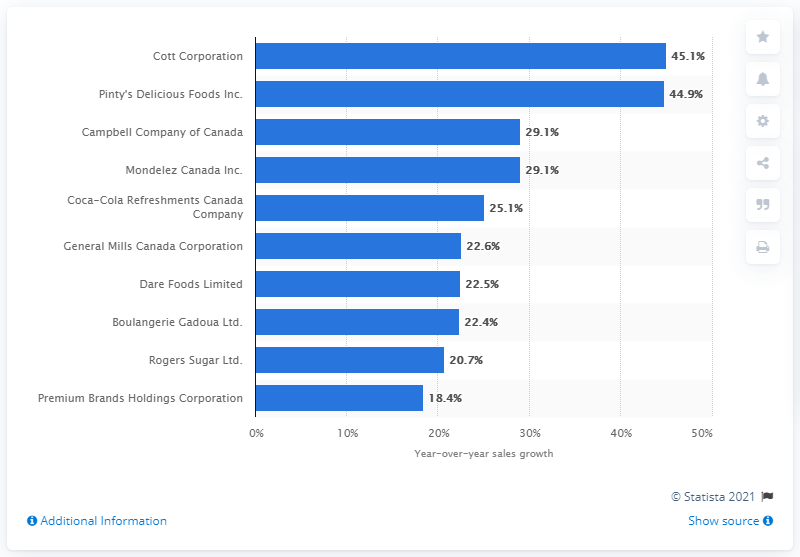What was the sales growth of Cott Corporation in 2017?
 45.1 